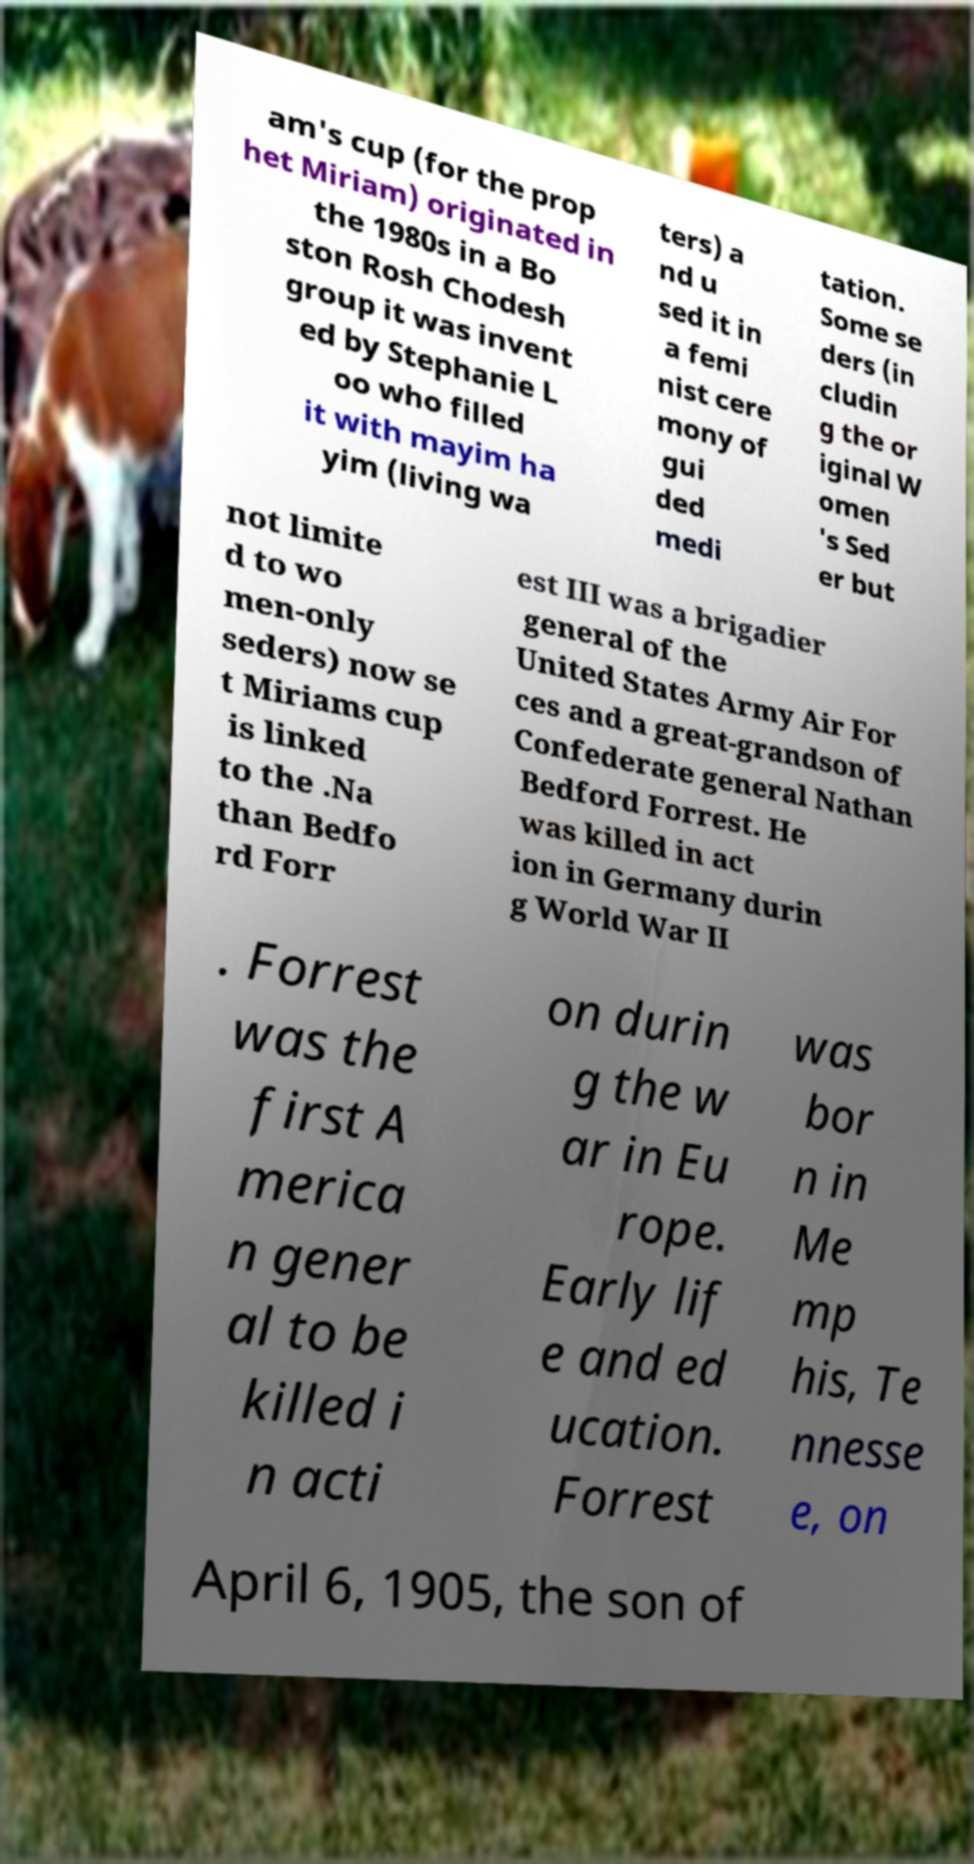What messages or text are displayed in this image? I need them in a readable, typed format. am's cup (for the prop het Miriam) originated in the 1980s in a Bo ston Rosh Chodesh group it was invent ed by Stephanie L oo who filled it with mayim ha yim (living wa ters) a nd u sed it in a femi nist cere mony of gui ded medi tation. Some se ders (in cludin g the or iginal W omen 's Sed er but not limite d to wo men-only seders) now se t Miriams cup is linked to the .Na than Bedfo rd Forr est III was a brigadier general of the United States Army Air For ces and a great-grandson of Confederate general Nathan Bedford Forrest. He was killed in act ion in Germany durin g World War II . Forrest was the first A merica n gener al to be killed i n acti on durin g the w ar in Eu rope. Early lif e and ed ucation. Forrest was bor n in Me mp his, Te nnesse e, on April 6, 1905, the son of 